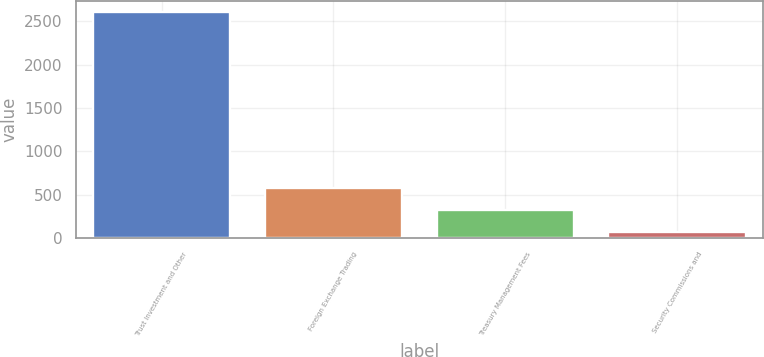Convert chart to OTSL. <chart><loc_0><loc_0><loc_500><loc_500><bar_chart><fcel>Trust Investment and Other<fcel>Foreign Exchange Trading<fcel>Treasury Management Fees<fcel>Security Commissions and<nl><fcel>2609.8<fcel>576.36<fcel>322.18<fcel>68<nl></chart> 